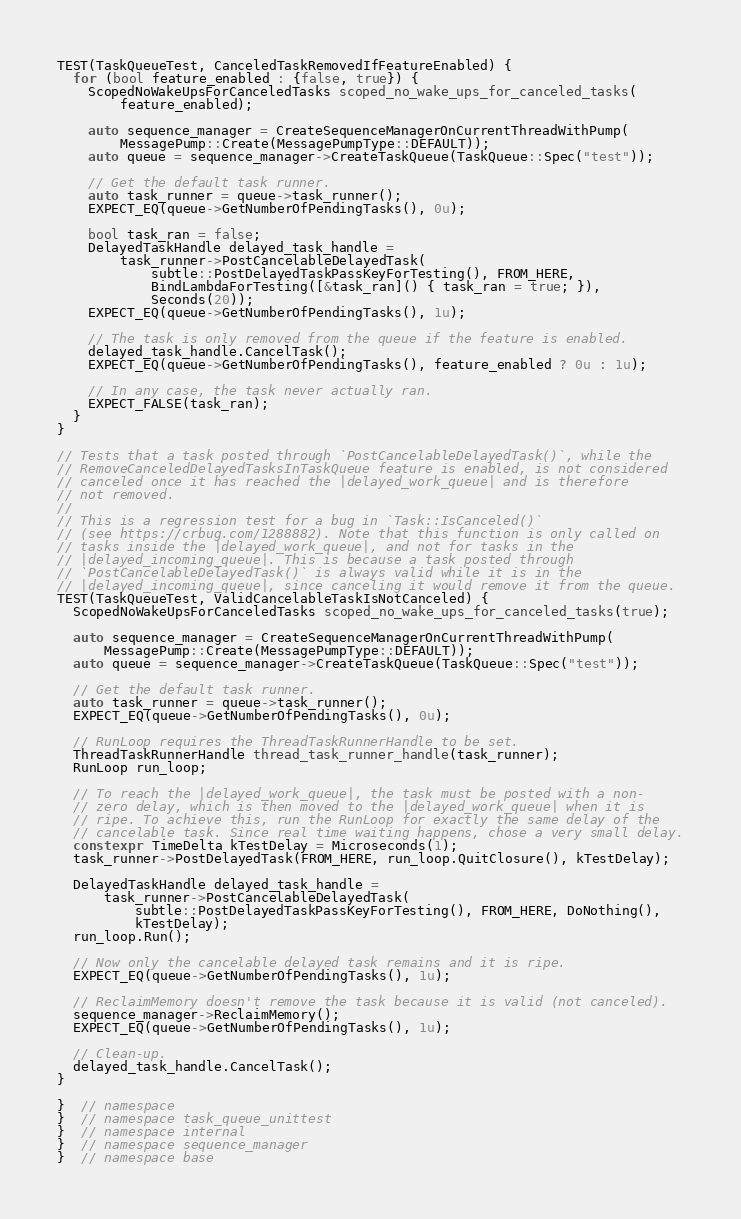<code> <loc_0><loc_0><loc_500><loc_500><_C++_>
TEST(TaskQueueTest, CanceledTaskRemovedIfFeatureEnabled) {
  for (bool feature_enabled : {false, true}) {
    ScopedNoWakeUpsForCanceledTasks scoped_no_wake_ups_for_canceled_tasks(
        feature_enabled);

    auto sequence_manager = CreateSequenceManagerOnCurrentThreadWithPump(
        MessagePump::Create(MessagePumpType::DEFAULT));
    auto queue = sequence_manager->CreateTaskQueue(TaskQueue::Spec("test"));

    // Get the default task runner.
    auto task_runner = queue->task_runner();
    EXPECT_EQ(queue->GetNumberOfPendingTasks(), 0u);

    bool task_ran = false;
    DelayedTaskHandle delayed_task_handle =
        task_runner->PostCancelableDelayedTask(
            subtle::PostDelayedTaskPassKeyForTesting(), FROM_HERE,
            BindLambdaForTesting([&task_ran]() { task_ran = true; }),
            Seconds(20));
    EXPECT_EQ(queue->GetNumberOfPendingTasks(), 1u);

    // The task is only removed from the queue if the feature is enabled.
    delayed_task_handle.CancelTask();
    EXPECT_EQ(queue->GetNumberOfPendingTasks(), feature_enabled ? 0u : 1u);

    // In any case, the task never actually ran.
    EXPECT_FALSE(task_ran);
  }
}

// Tests that a task posted through `PostCancelableDelayedTask()`, while the
// RemoveCanceledDelayedTasksInTaskQueue feature is enabled, is not considered
// canceled once it has reached the |delayed_work_queue| and is therefore
// not removed.
//
// This is a regression test for a bug in `Task::IsCanceled()`
// (see https://crbug.com/1288882). Note that this function is only called on
// tasks inside the |delayed_work_queue|, and not for tasks in the
// |delayed_incoming_queue|. This is because a task posted through
// `PostCancelableDelayedTask()` is always valid while it is in the
// |delayed_incoming_queue|, since canceling it would remove it from the queue.
TEST(TaskQueueTest, ValidCancelableTaskIsNotCanceled) {
  ScopedNoWakeUpsForCanceledTasks scoped_no_wake_ups_for_canceled_tasks(true);

  auto sequence_manager = CreateSequenceManagerOnCurrentThreadWithPump(
      MessagePump::Create(MessagePumpType::DEFAULT));
  auto queue = sequence_manager->CreateTaskQueue(TaskQueue::Spec("test"));

  // Get the default task runner.
  auto task_runner = queue->task_runner();
  EXPECT_EQ(queue->GetNumberOfPendingTasks(), 0u);

  // RunLoop requires the ThreadTaskRunnerHandle to be set.
  ThreadTaskRunnerHandle thread_task_runner_handle(task_runner);
  RunLoop run_loop;

  // To reach the |delayed_work_queue|, the task must be posted with a non-
  // zero delay, which is then moved to the |delayed_work_queue| when it is
  // ripe. To achieve this, run the RunLoop for exactly the same delay of the
  // cancelable task. Since real time waiting happens, chose a very small delay.
  constexpr TimeDelta kTestDelay = Microseconds(1);
  task_runner->PostDelayedTask(FROM_HERE, run_loop.QuitClosure(), kTestDelay);

  DelayedTaskHandle delayed_task_handle =
      task_runner->PostCancelableDelayedTask(
          subtle::PostDelayedTaskPassKeyForTesting(), FROM_HERE, DoNothing(),
          kTestDelay);
  run_loop.Run();

  // Now only the cancelable delayed task remains and it is ripe.
  EXPECT_EQ(queue->GetNumberOfPendingTasks(), 1u);

  // ReclaimMemory doesn't remove the task because it is valid (not canceled).
  sequence_manager->ReclaimMemory();
  EXPECT_EQ(queue->GetNumberOfPendingTasks(), 1u);

  // Clean-up.
  delayed_task_handle.CancelTask();
}

}  // namespace
}  // namespace task_queue_unittest
}  // namespace internal
}  // namespace sequence_manager
}  // namespace base
</code> 